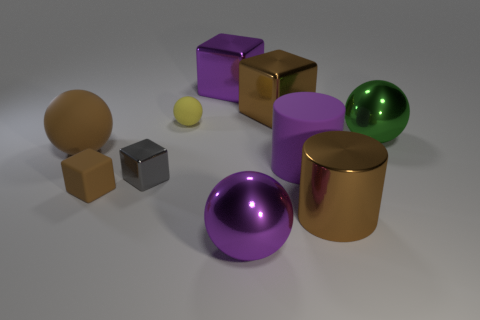There is a cylinder to the left of the brown cylinder; what size is it?
Offer a terse response. Large. Are there any other things of the same color as the tiny metallic object?
Provide a succinct answer. No. Is there a large purple ball on the left side of the metallic sphere on the left side of the sphere right of the brown shiny cylinder?
Keep it short and to the point. No. Does the large sphere in front of the tiny brown matte cube have the same color as the matte block?
Provide a short and direct response. No. How many cubes are tiny yellow metal things or tiny brown things?
Keep it short and to the point. 1. What is the shape of the big rubber object left of the purple metallic thing that is in front of the gray metallic thing?
Provide a succinct answer. Sphere. What size is the brown cube in front of the large metal sphere that is behind the metal ball in front of the rubber block?
Make the answer very short. Small. Does the gray shiny cube have the same size as the purple metallic block?
Your answer should be very brief. No. What number of objects are either big shiny cylinders or large purple balls?
Your answer should be compact. 2. What size is the brown matte thing that is behind the brown block in front of the brown sphere?
Give a very brief answer. Large. 